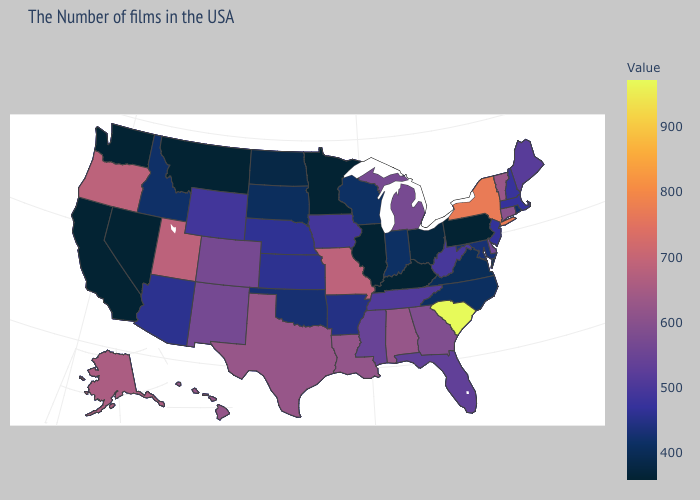Does the map have missing data?
Write a very short answer. No. Does Pennsylvania have the lowest value in the USA?
Concise answer only. Yes. Does Illinois have the lowest value in the MidWest?
Be succinct. Yes. Which states have the lowest value in the Northeast?
Be succinct. Pennsylvania. Which states have the lowest value in the MidWest?
Quick response, please. Illinois, Minnesota. Which states hav the highest value in the Northeast?
Be succinct. New York. 